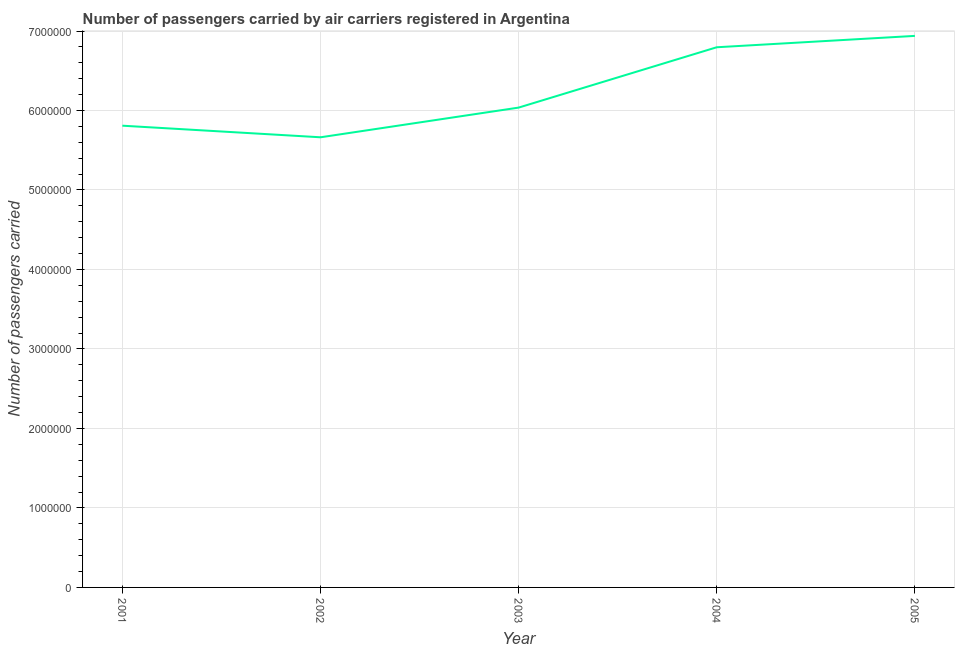What is the number of passengers carried in 2002?
Ensure brevity in your answer.  5.66e+06. Across all years, what is the maximum number of passengers carried?
Give a very brief answer. 6.94e+06. Across all years, what is the minimum number of passengers carried?
Offer a very short reply. 5.66e+06. What is the sum of the number of passengers carried?
Give a very brief answer. 3.12e+07. What is the difference between the number of passengers carried in 2002 and 2003?
Offer a very short reply. -3.73e+05. What is the average number of passengers carried per year?
Make the answer very short. 6.25e+06. What is the median number of passengers carried?
Ensure brevity in your answer.  6.04e+06. In how many years, is the number of passengers carried greater than 200000 ?
Keep it short and to the point. 5. What is the ratio of the number of passengers carried in 2001 to that in 2005?
Provide a short and direct response. 0.84. What is the difference between the highest and the second highest number of passengers carried?
Your response must be concise. 1.43e+05. What is the difference between the highest and the lowest number of passengers carried?
Provide a short and direct response. 1.28e+06. Does the number of passengers carried monotonically increase over the years?
Provide a short and direct response. No. How many lines are there?
Keep it short and to the point. 1. How many years are there in the graph?
Offer a terse response. 5. Does the graph contain any zero values?
Give a very brief answer. No. What is the title of the graph?
Keep it short and to the point. Number of passengers carried by air carriers registered in Argentina. What is the label or title of the X-axis?
Make the answer very short. Year. What is the label or title of the Y-axis?
Keep it short and to the point. Number of passengers carried. What is the Number of passengers carried of 2001?
Give a very brief answer. 5.81e+06. What is the Number of passengers carried of 2002?
Provide a succinct answer. 5.66e+06. What is the Number of passengers carried of 2003?
Offer a very short reply. 6.04e+06. What is the Number of passengers carried in 2004?
Offer a terse response. 6.80e+06. What is the Number of passengers carried of 2005?
Provide a succinct answer. 6.94e+06. What is the difference between the Number of passengers carried in 2001 and 2002?
Offer a terse response. 1.46e+05. What is the difference between the Number of passengers carried in 2001 and 2003?
Your answer should be compact. -2.28e+05. What is the difference between the Number of passengers carried in 2001 and 2004?
Provide a succinct answer. -9.87e+05. What is the difference between the Number of passengers carried in 2001 and 2005?
Keep it short and to the point. -1.13e+06. What is the difference between the Number of passengers carried in 2002 and 2003?
Keep it short and to the point. -3.73e+05. What is the difference between the Number of passengers carried in 2002 and 2004?
Keep it short and to the point. -1.13e+06. What is the difference between the Number of passengers carried in 2002 and 2005?
Offer a very short reply. -1.28e+06. What is the difference between the Number of passengers carried in 2003 and 2004?
Make the answer very short. -7.59e+05. What is the difference between the Number of passengers carried in 2003 and 2005?
Keep it short and to the point. -9.02e+05. What is the difference between the Number of passengers carried in 2004 and 2005?
Make the answer very short. -1.43e+05. What is the ratio of the Number of passengers carried in 2001 to that in 2002?
Your answer should be very brief. 1.03. What is the ratio of the Number of passengers carried in 2001 to that in 2003?
Offer a terse response. 0.96. What is the ratio of the Number of passengers carried in 2001 to that in 2004?
Give a very brief answer. 0.85. What is the ratio of the Number of passengers carried in 2001 to that in 2005?
Offer a terse response. 0.84. What is the ratio of the Number of passengers carried in 2002 to that in 2003?
Ensure brevity in your answer.  0.94. What is the ratio of the Number of passengers carried in 2002 to that in 2004?
Offer a very short reply. 0.83. What is the ratio of the Number of passengers carried in 2002 to that in 2005?
Your response must be concise. 0.82. What is the ratio of the Number of passengers carried in 2003 to that in 2004?
Provide a short and direct response. 0.89. What is the ratio of the Number of passengers carried in 2003 to that in 2005?
Provide a short and direct response. 0.87. 